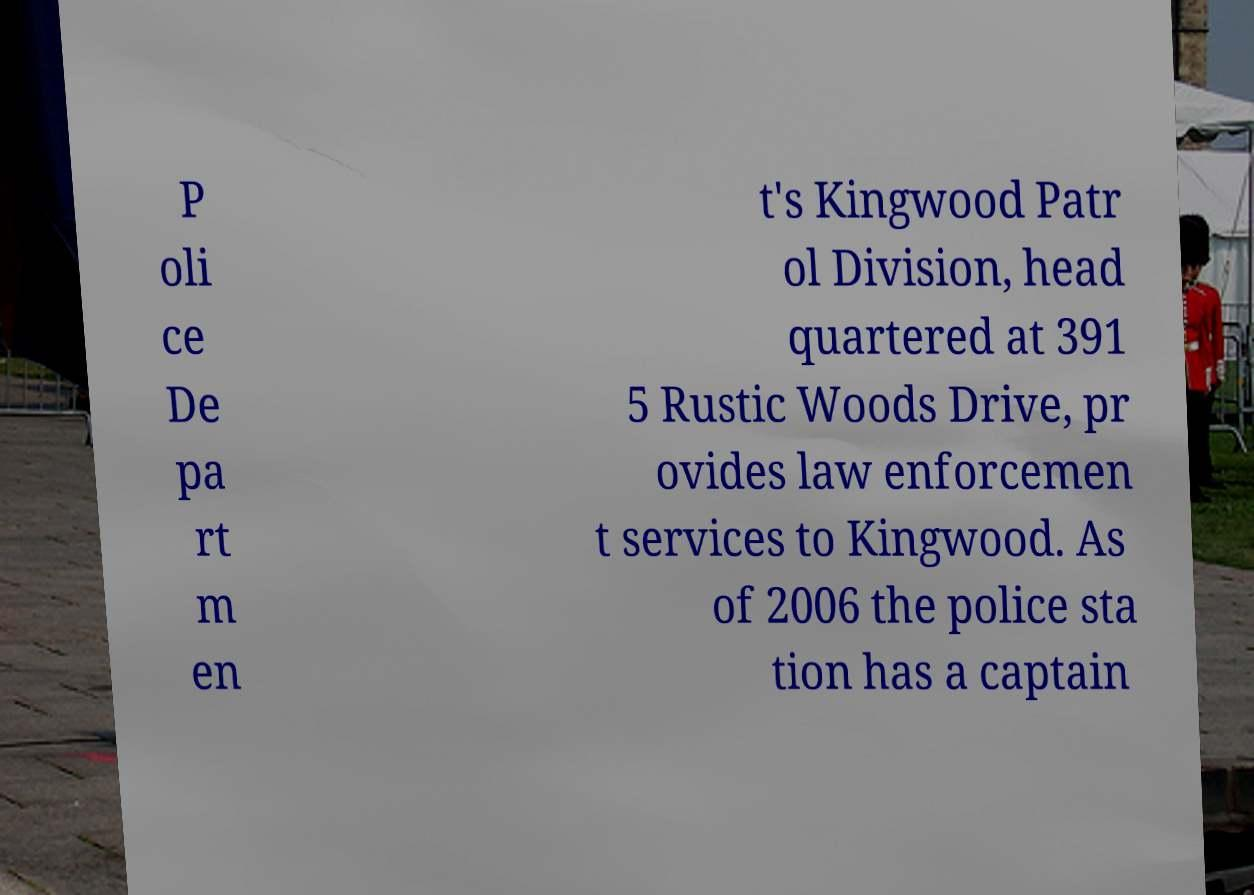What messages or text are displayed in this image? I need them in a readable, typed format. P oli ce De pa rt m en t's Kingwood Patr ol Division, head quartered at 391 5 Rustic Woods Drive, pr ovides law enforcemen t services to Kingwood. As of 2006 the police sta tion has a captain 